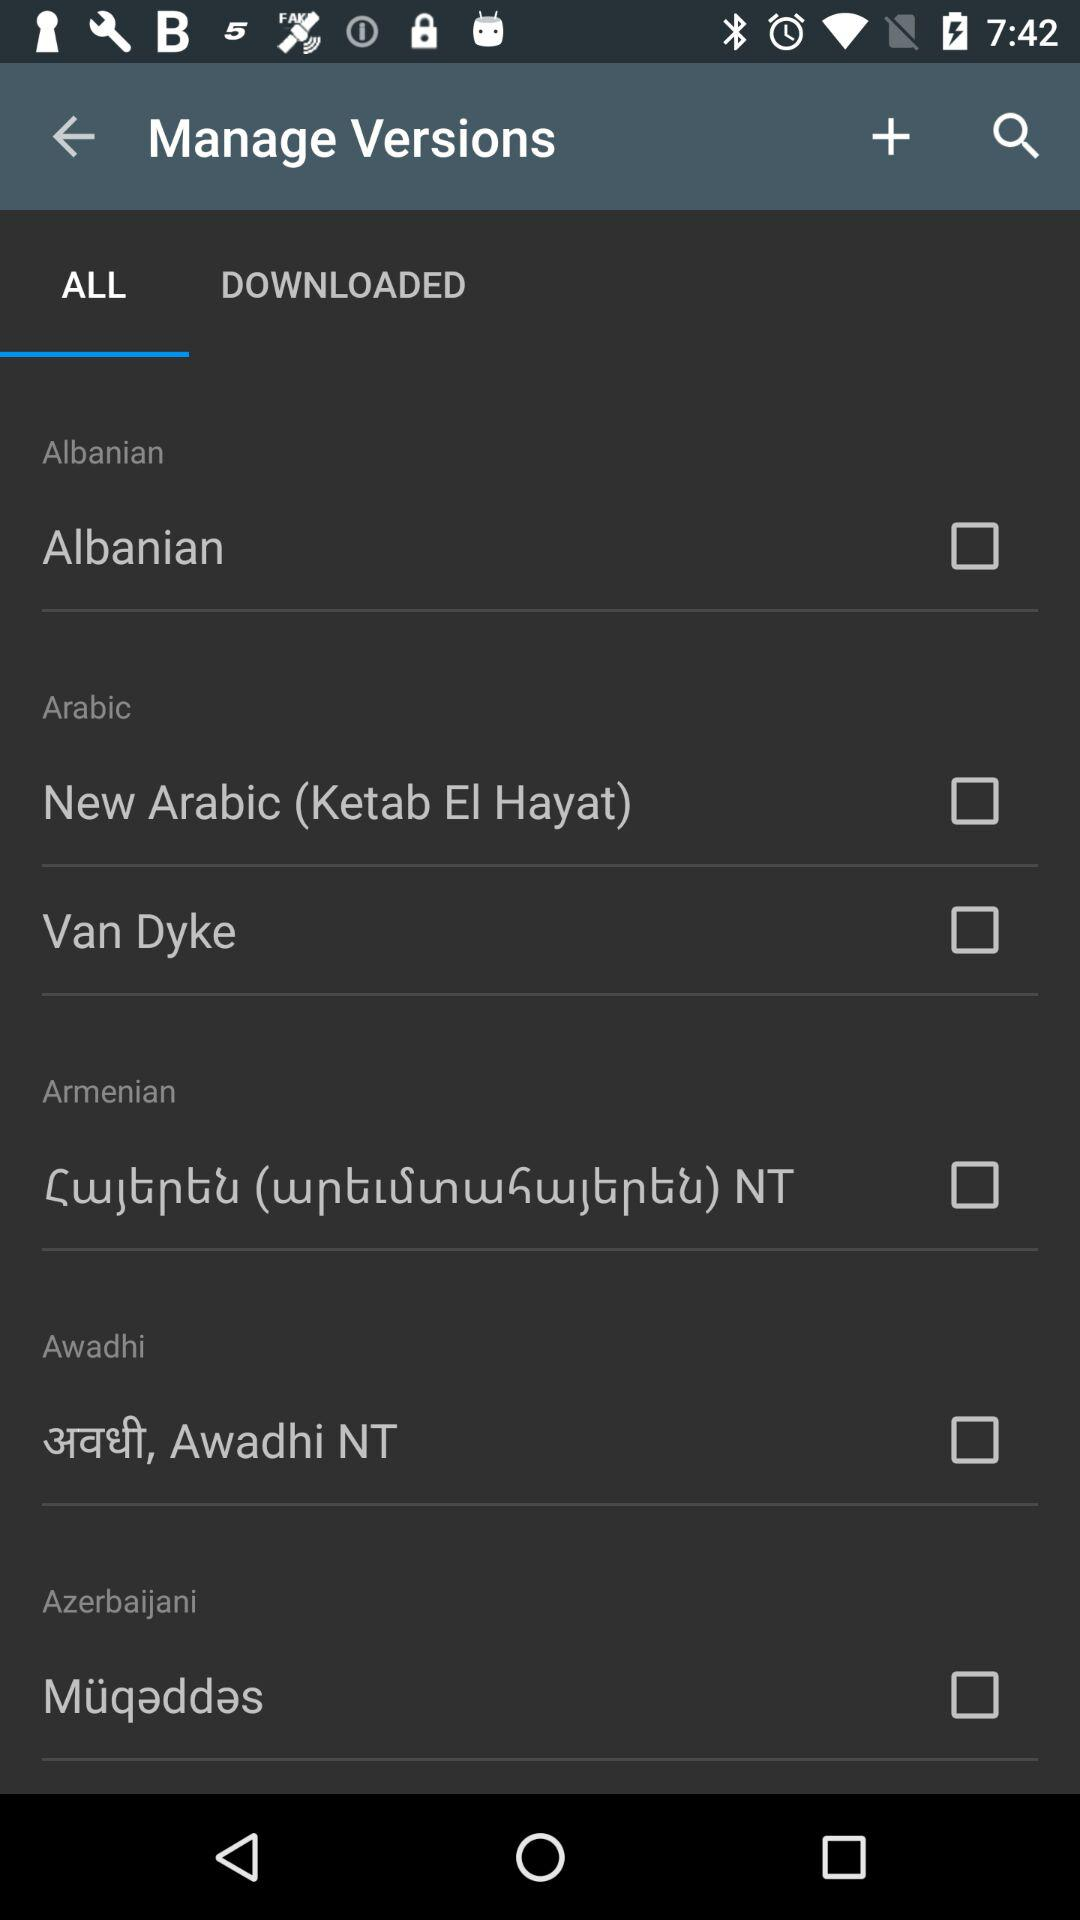Which versions are downloaded?
When the provided information is insufficient, respond with <no answer>. <no answer> 